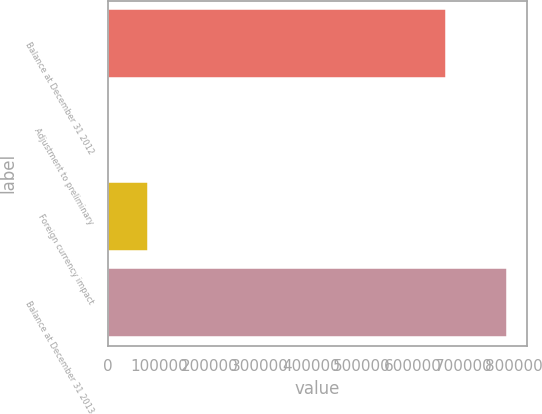Convert chart. <chart><loc_0><loc_0><loc_500><loc_500><bar_chart><fcel>Balance at December 31 2012<fcel>Adjustment to preliminary<fcel>Foreign currency impact<fcel>Balance at December 31 2013<nl><fcel>666022<fcel>448<fcel>79046.5<fcel>786433<nl></chart> 